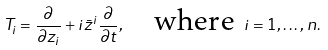<formula> <loc_0><loc_0><loc_500><loc_500>T _ { i } = \frac { \partial } { \partial z _ { i } } + i \bar { z } ^ { i } \frac { \partial } { \partial t } , \quad \text {where } i = 1 , \dots , n .</formula> 